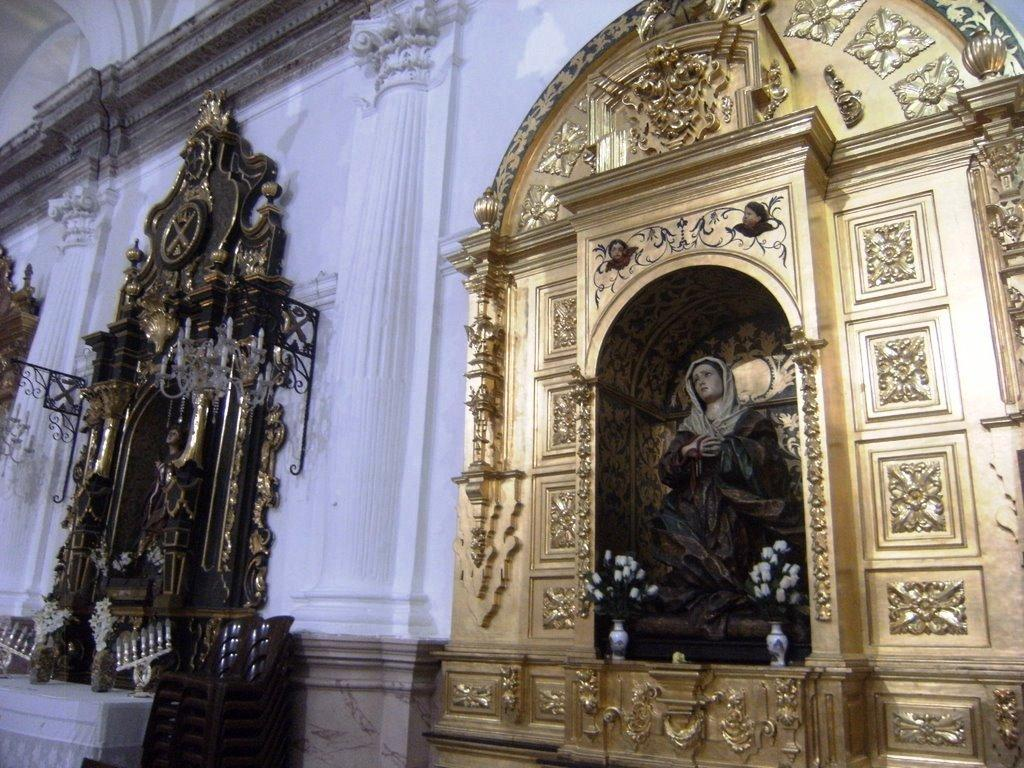What type of art can be seen in the image? There are sculptures in the image. What can be found on the wall in the image? There are structures on the wall in the image. What architectural elements are present in the image? There are pillars in the image. Can you tell me how many snakes are slithering around the pillars in the image? There are no snakes present in the image; it features sculptures, structures on the wall, and pillars. What type of steam is visible coming from the sculptures in the image? There is no steam present in the image; it only features sculptures, structures on the wall, and pillars. 